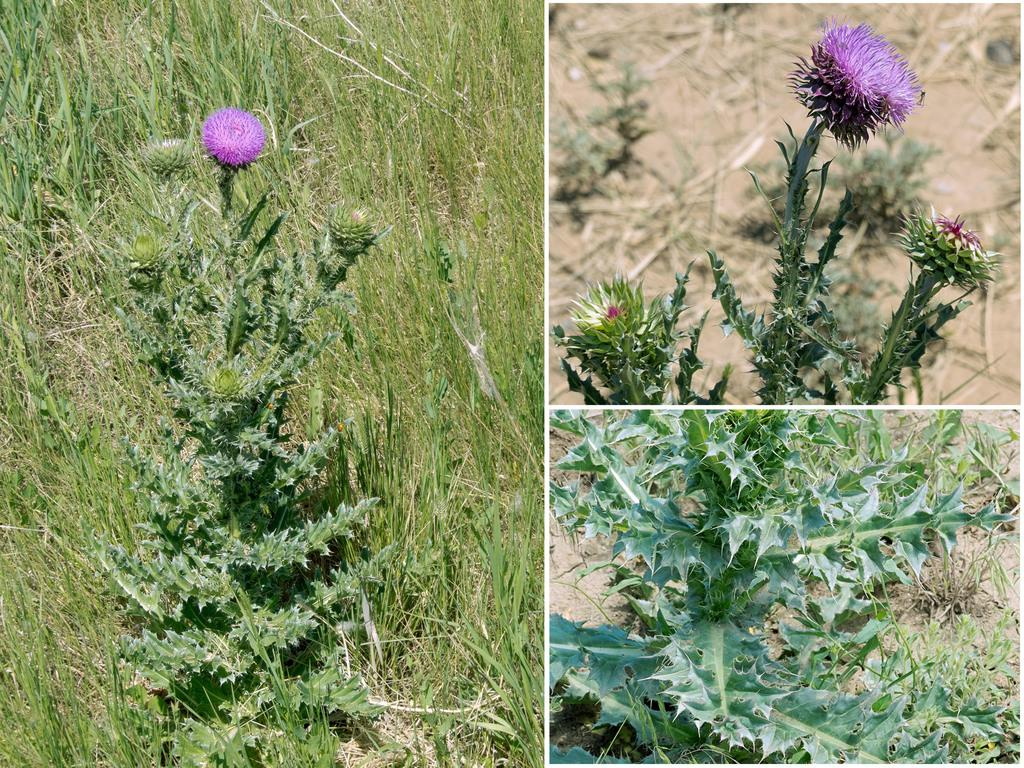What type of images are present in the collage? The collage contains images of flower plants. Can you describe the main subject of the collage? The main subject of the collage is a collection of flower plants. Is there a swing visible in the collage? No, there is no swing present in the collage; it only contains images of flower plants. What type of frog can be seen in the skirt of the flower plant? There is no frog or skirt present in the collage; it only features images of flower plants. 